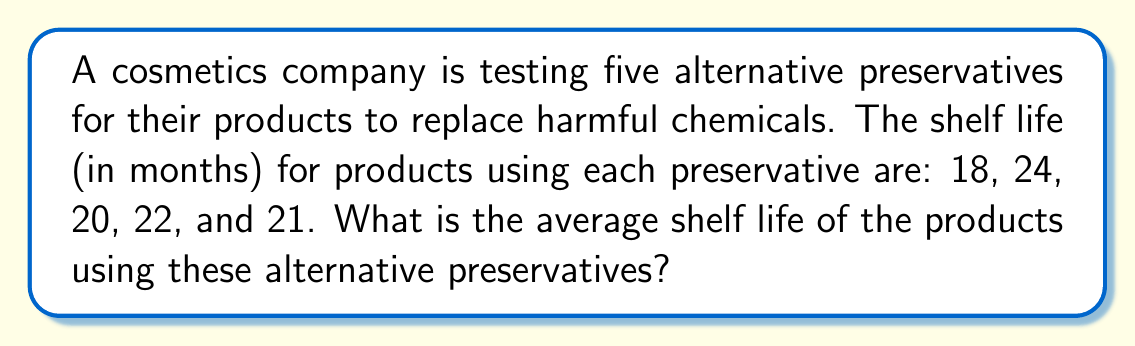Can you solve this math problem? To find the average shelf life, we need to calculate the arithmetic mean of the given data. The formula for the arithmetic mean is:

$$ \text{Average} = \frac{\text{Sum of all values}}{\text{Number of values}} $$

Let's follow these steps:

1) First, we sum up all the shelf life values:
   $18 + 24 + 20 + 22 + 21 = 105$ months

2) Next, we count the number of values:
   There are 5 different preservatives, so we have 5 values.

3) Now, we can apply the formula:
   $$ \text{Average} = \frac{105}{5} = 21 $$

Therefore, the average shelf life of the products using these alternative preservatives is 21 months.
Answer: $21$ months 